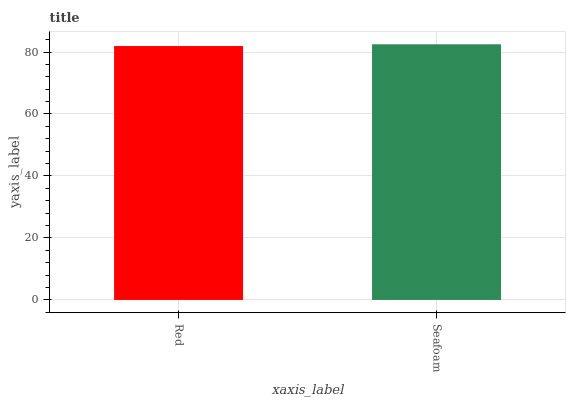Is Red the minimum?
Answer yes or no. Yes. Is Seafoam the maximum?
Answer yes or no. Yes. Is Seafoam the minimum?
Answer yes or no. No. Is Seafoam greater than Red?
Answer yes or no. Yes. Is Red less than Seafoam?
Answer yes or no. Yes. Is Red greater than Seafoam?
Answer yes or no. No. Is Seafoam less than Red?
Answer yes or no. No. Is Seafoam the high median?
Answer yes or no. Yes. Is Red the low median?
Answer yes or no. Yes. Is Red the high median?
Answer yes or no. No. Is Seafoam the low median?
Answer yes or no. No. 